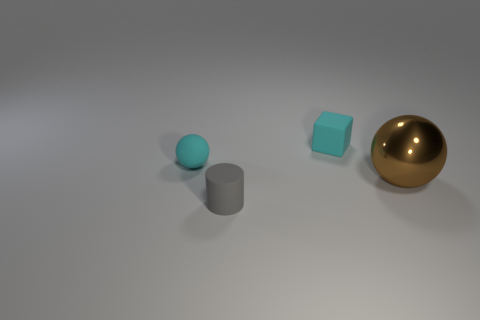What is the object on the right side of the tiny cube made of? metal 